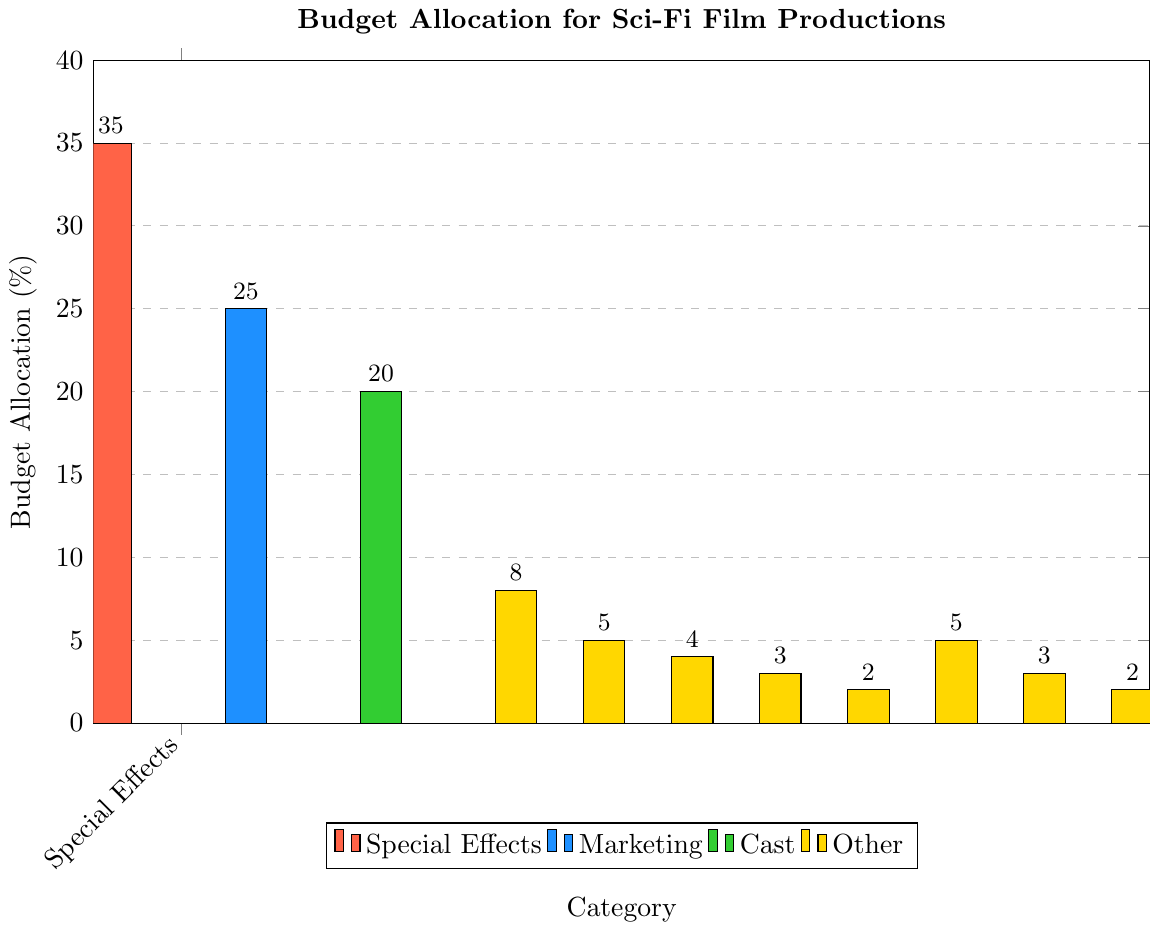which budget category has the highest allocation? The bar chart shows that the 'Special Effects' category has the tallest bar, indicating the highest budget allocation percentage.
Answer: Special Effects Which two categories together constitute 50% of the budget? According to the chart, 'Special Effects' accounts for 35% and 'Marketing' accounts for 25%. Adding these together: 35% + 25% = 60%. So, these two categories together make up more than 50%.
Answer: Special Effects and Marketing What is the total budget allocation of Cast and Production Design combined? From the chart, the budget for 'Cast' is 20% and for 'Production Design' is 8%. Adding these together: 20% + 8% = 28%.
Answer: 28% Which category has the lowest budget allocation? The bar chart shows that 'Screenplay' and 'Miscellaneous' categories both have the smallest bars, each representing 2% of the budget.
Answer: Screenplay and Miscellaneous Is the budget allocated to Post-Production greater than that of Costume and Makeup? According to the chart, the budget for 'Post-Production' is 5% while 'Costume and Makeup' is 4%. Since 5% is greater than 4%, the budget allocated to Post-Production is indeed greater.
Answer: Yes What is the average budget allocation for the three categories with the highest percentages? The three categories with the highest percentages are 'Special Effects' (35%), 'Marketing' (25%), and 'Cast' (20%). The average is calculated as: (35 + 25 + 20) / 3 = 80 / 3 ≈ 26.67%.
Answer: approximately 26.67% By how much does the budget allocation for Sound and Music differ from that for Cinematography? The chart shows that 'Sound and Music' has a budget of 3% and 'Cinematography' has a budget of 5%. The difference is 5% - 3% = 2%.
Answer: 2% What proportion of the entire budget is allocated to categories related to visual elements (Special Effects, Production Design, Cinematography, Costume and Makeup)? The budget percentages for these categories are: Special Effects (35%), Production Design (8%), Cinematography (5%), and Costume and Makeup (4%). Summing these up: 35% + 8% + 5% + 4% = 52%.
Answer: 52% How much more budget is allocated to Marketing compared to the sum of Locations and Permits and Miscellaneous? The chart shows 'Marketing' at 25%, 'Locations and Permits' at 3%, and 'Miscellaneous' at 2%. Summing Locations and Miscellaneous: 3% + 2% = 5%. Then, the difference is: 25% - 5% = 20%.
Answer: 20% What percentage of the budget is allocated to categories outside of Special Effects, Marketing, and Cast? The percentages for Special Effects, Marketing, and Cast are 35%, 25%, and 20% respectively. Summing these up: 35% + 25% + 20% = 80%. Therefore, the remaining budget is: 100% - 80% = 20%.
Answer: 20% 